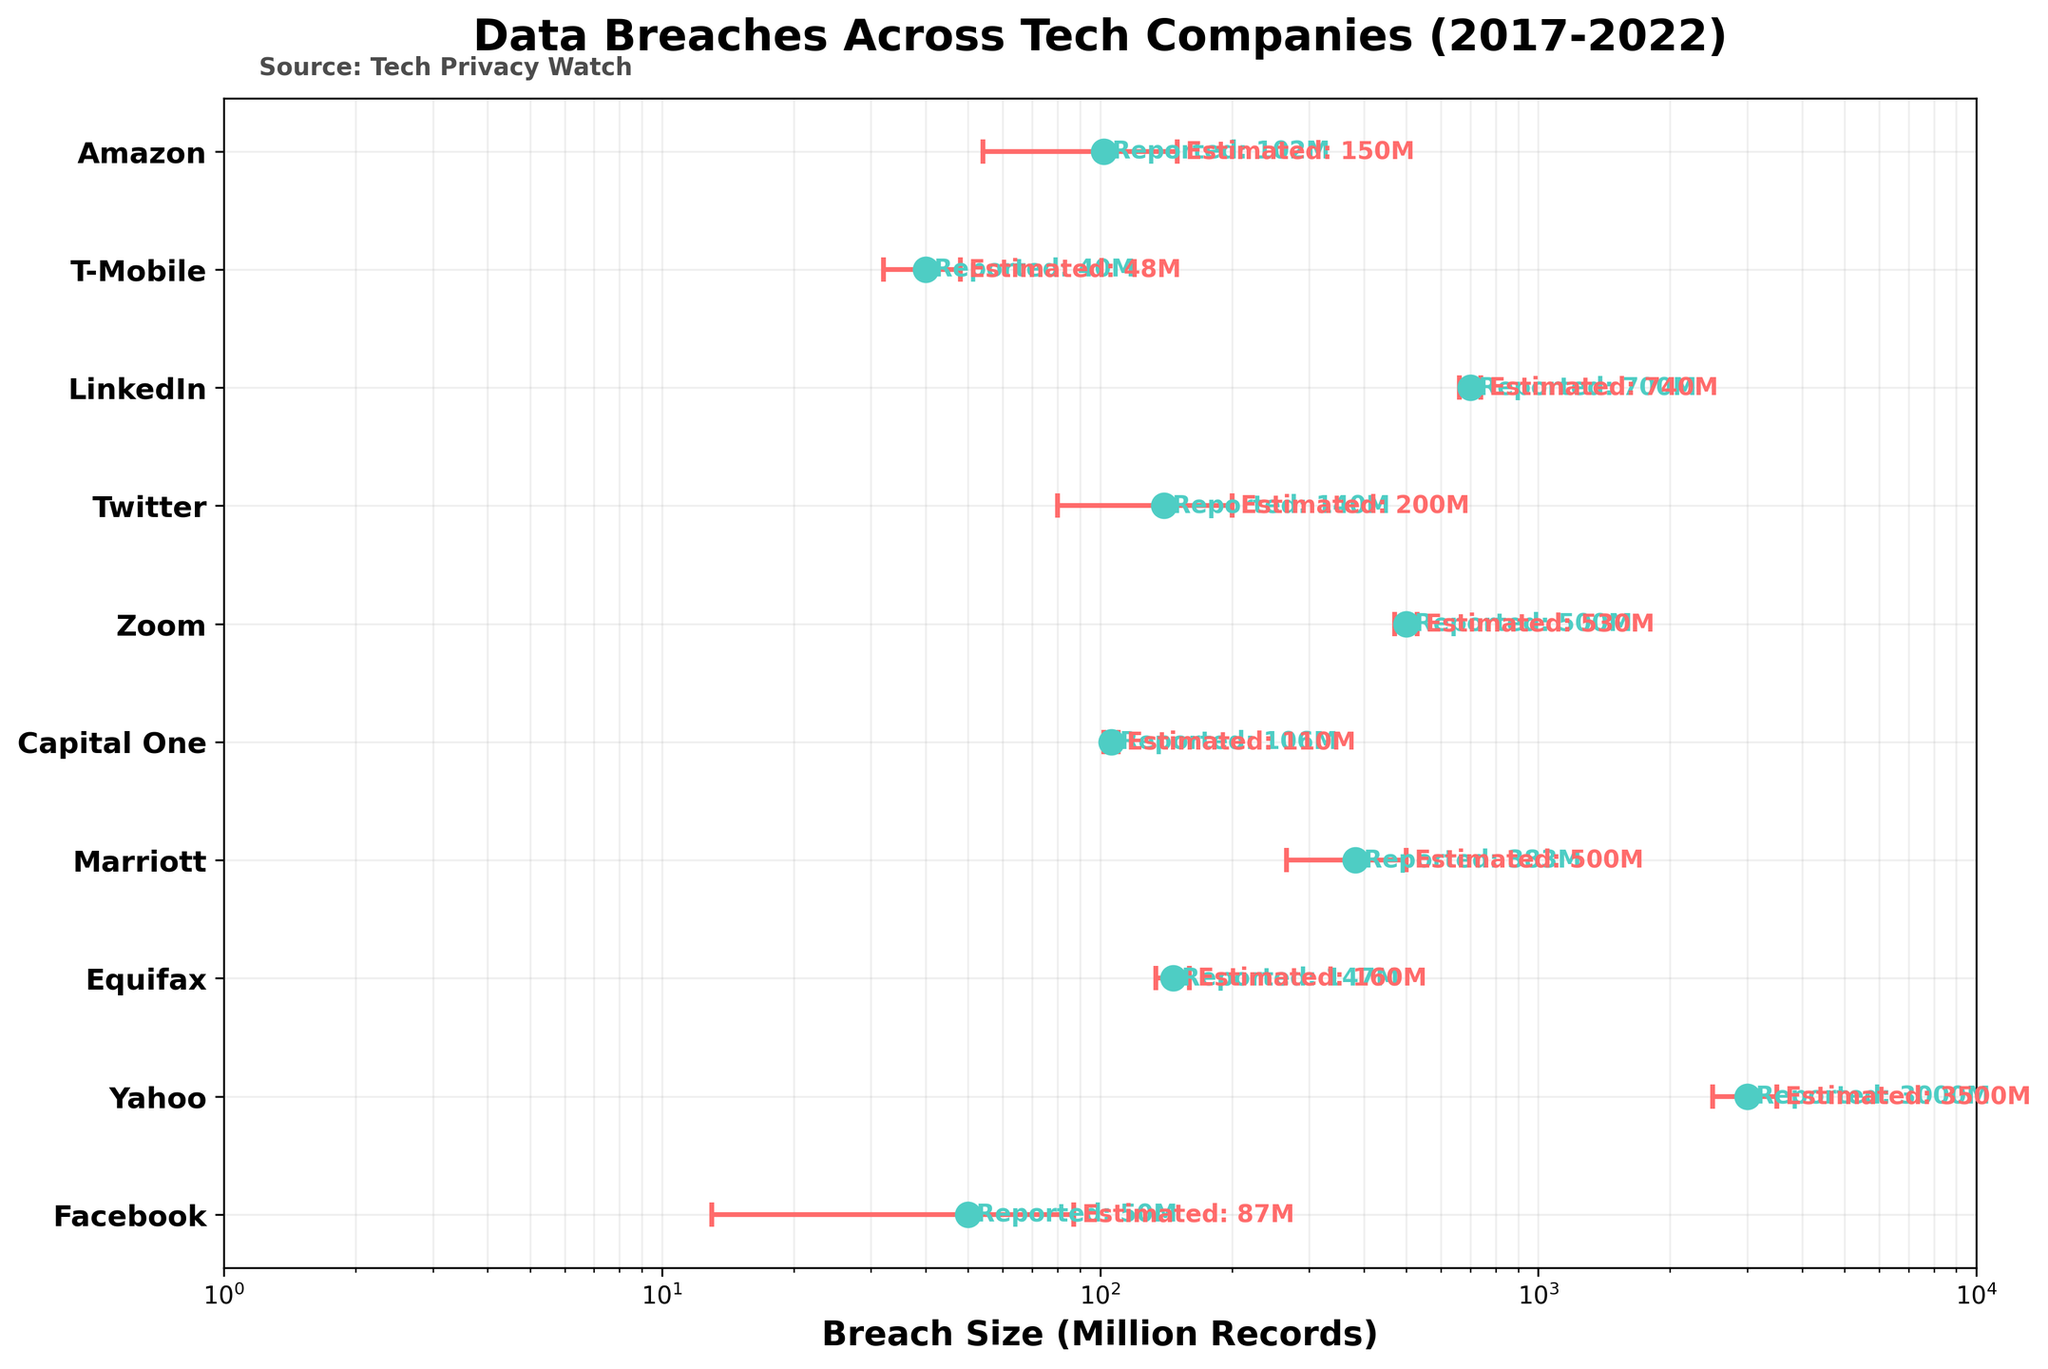what is the title of the figure? The title of the figure is usually displayed at the top of the plot in bold letters.
Answer: Data Breaches Across Tech Companies (2017-2022) How many companies are represented in the plot? Count the number of unique y-ticks, each representing a different company.
Answer: 10 What is the reported breach size for Yahoo in 2017? Locate Yahoo on the y-axis and read the corresponding reported breach size on the x-axis.
Answer: 3000 million records Which company has the smallest reported breach size? Identify the smallest value among the reported breach sizes plotted on the x-axis.
Answer: T-Mobile What is the error margin for Marriott in 2019? Locate Marriott on the y-axis and read the error bar's length on the x-axis, denoting the difference between the reported and estimated breach sizes.
Answer: 117 million records Which company's reported breach size lies closest to 100 million records? Locate the data points near 100 million and identify the corresponding company on the y-axis.
Answer: Amazon How does the average estimated breach size for 2021 compare to the average reported breach size for 2021? Calculate the average for estimated and reported breach sizes for 2021 and compare the values.
Answer: Estimated: (200 + 740 + 48)/3 = 329.33, Reported: (140 + 700 + 40)/3 ≈ 293.33 million records. The average estimated size is larger Which company shows the largest difference between reported and estimated breach sizes? Calculate the difference between reported and estimated sizes for each company and identify the largest one.
Answer: Yahoo (500 million records) What's the relationship between the error bars (error margins) and the level of uncertainty in breach estimates? Longer error bars indicate higher uncertainty between the reported and estimated sizes.
Answer: The uncertainty increases with longer error bars 